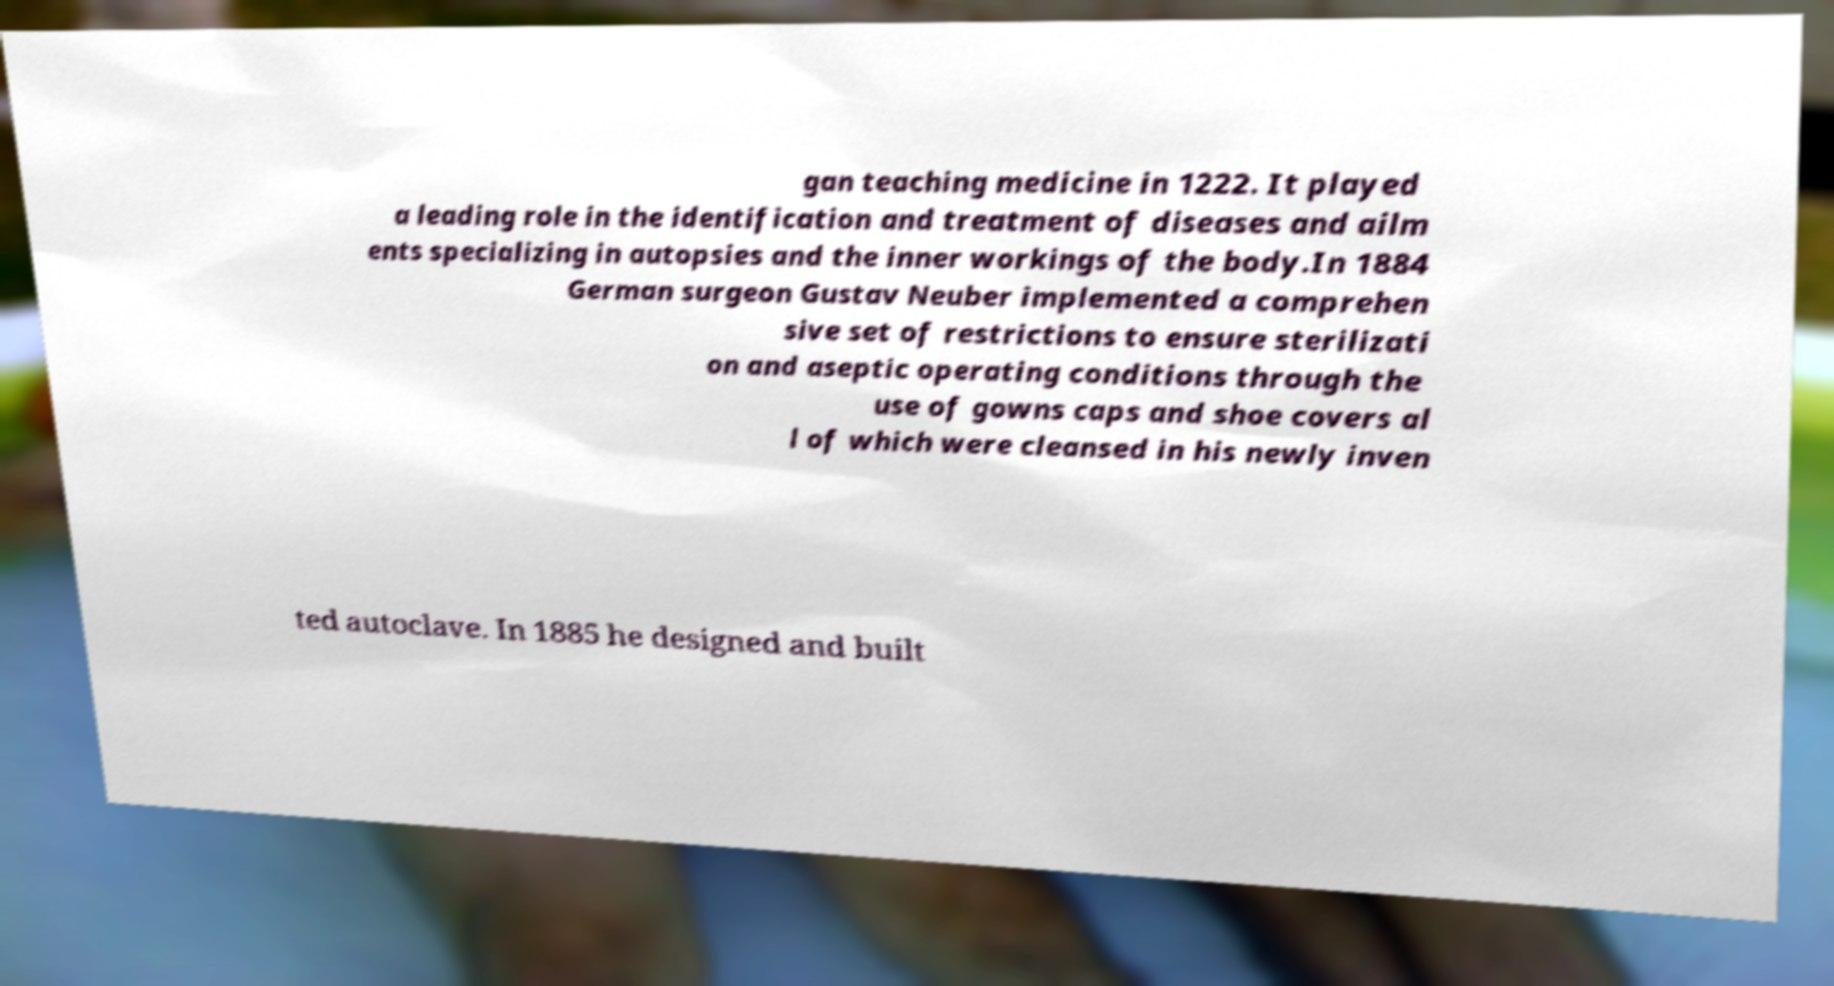Can you accurately transcribe the text from the provided image for me? gan teaching medicine in 1222. It played a leading role in the identification and treatment of diseases and ailm ents specializing in autopsies and the inner workings of the body.In 1884 German surgeon Gustav Neuber implemented a comprehen sive set of restrictions to ensure sterilizati on and aseptic operating conditions through the use of gowns caps and shoe covers al l of which were cleansed in his newly inven ted autoclave. In 1885 he designed and built 